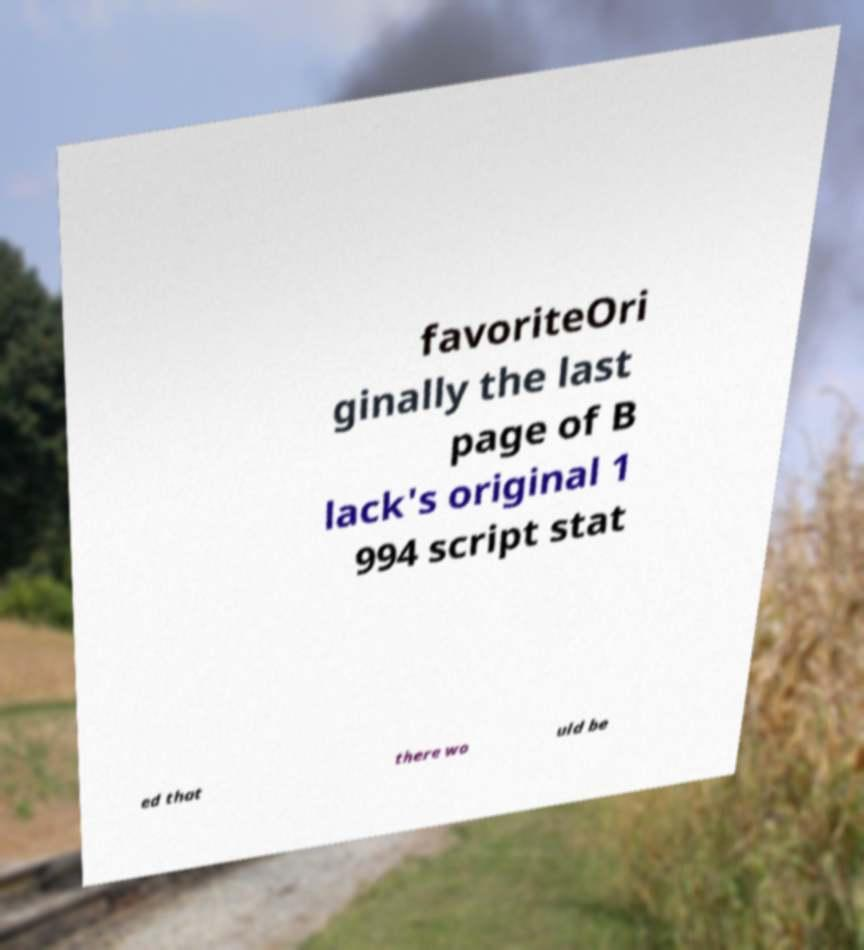For documentation purposes, I need the text within this image transcribed. Could you provide that? favoriteOri ginally the last page of B lack's original 1 994 script stat ed that there wo uld be 